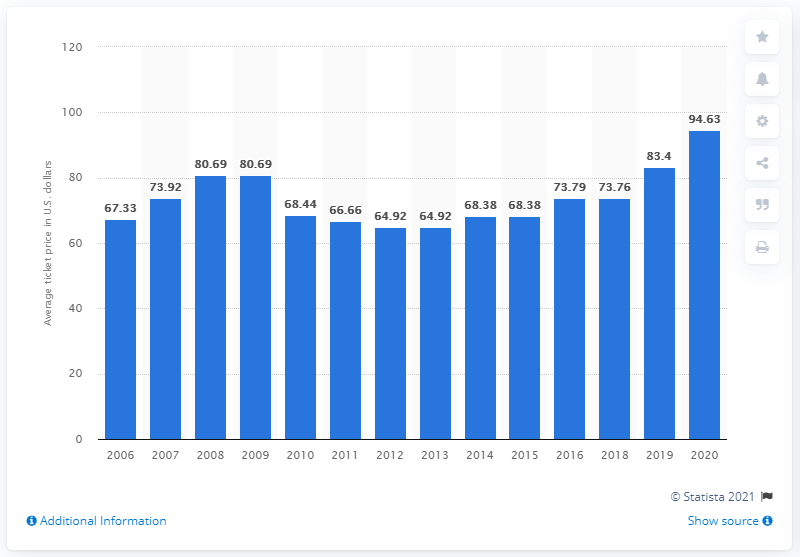List a handful of essential elements in this visual. The average ticket price for Kansas City Chiefs games in 2020 was $94.63. 